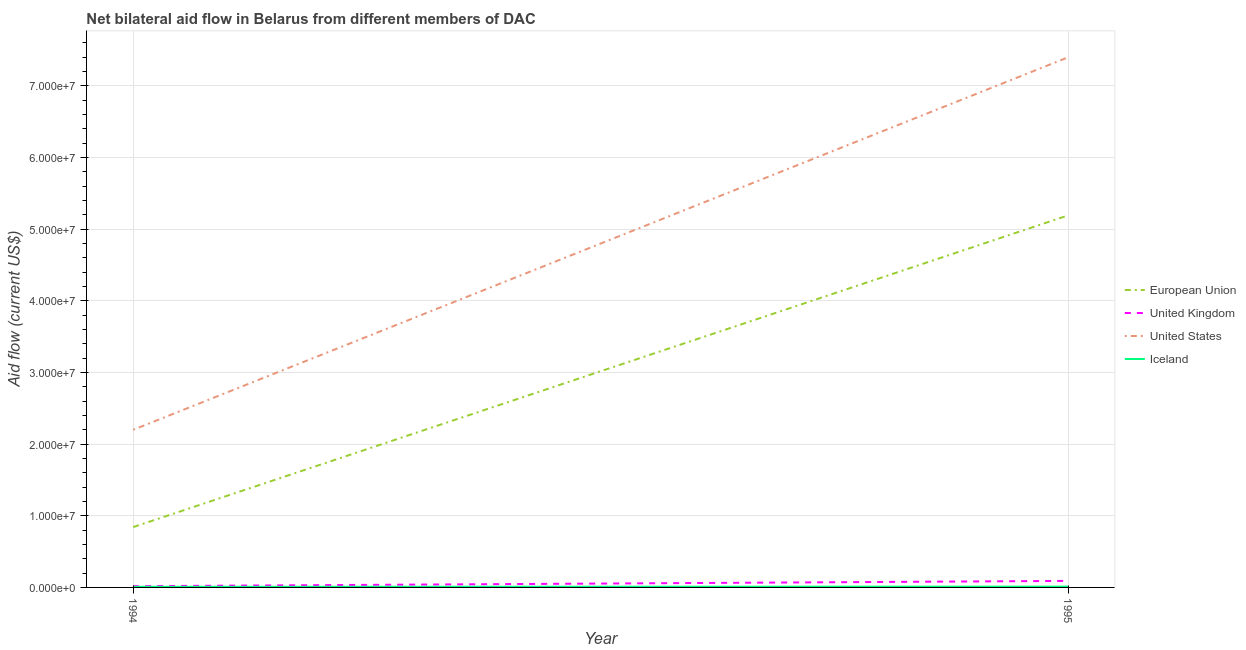How many different coloured lines are there?
Offer a very short reply. 4. Does the line corresponding to amount of aid given by us intersect with the line corresponding to amount of aid given by eu?
Your answer should be compact. No. What is the amount of aid given by eu in 1994?
Provide a succinct answer. 8.42e+06. Across all years, what is the maximum amount of aid given by eu?
Give a very brief answer. 5.19e+07. Across all years, what is the minimum amount of aid given by iceland?
Make the answer very short. 8.00e+04. In which year was the amount of aid given by uk maximum?
Keep it short and to the point. 1995. In which year was the amount of aid given by uk minimum?
Give a very brief answer. 1994. What is the total amount of aid given by eu in the graph?
Your response must be concise. 6.04e+07. What is the difference between the amount of aid given by eu in 1994 and that in 1995?
Provide a short and direct response. -4.35e+07. What is the difference between the amount of aid given by iceland in 1994 and the amount of aid given by eu in 1995?
Ensure brevity in your answer.  -5.18e+07. What is the average amount of aid given by uk per year?
Provide a short and direct response. 5.40e+05. In the year 1995, what is the difference between the amount of aid given by us and amount of aid given by iceland?
Give a very brief answer. 7.39e+07. In how many years, is the amount of aid given by us greater than 46000000 US$?
Give a very brief answer. 1. What is the ratio of the amount of aid given by uk in 1994 to that in 1995?
Your response must be concise. 0.19. Is the amount of aid given by iceland in 1994 less than that in 1995?
Keep it short and to the point. Yes. Is the amount of aid given by iceland strictly less than the amount of aid given by uk over the years?
Provide a succinct answer. Yes. How many lines are there?
Make the answer very short. 4. What is the difference between two consecutive major ticks on the Y-axis?
Ensure brevity in your answer.  1.00e+07. Are the values on the major ticks of Y-axis written in scientific E-notation?
Provide a succinct answer. Yes. Does the graph contain any zero values?
Offer a terse response. No. Where does the legend appear in the graph?
Provide a succinct answer. Center right. How many legend labels are there?
Provide a short and direct response. 4. How are the legend labels stacked?
Provide a short and direct response. Vertical. What is the title of the graph?
Keep it short and to the point. Net bilateral aid flow in Belarus from different members of DAC. What is the Aid flow (current US$) of European Union in 1994?
Offer a terse response. 8.42e+06. What is the Aid flow (current US$) in United Kingdom in 1994?
Your answer should be compact. 1.70e+05. What is the Aid flow (current US$) of United States in 1994?
Ensure brevity in your answer.  2.20e+07. What is the Aid flow (current US$) in Iceland in 1994?
Keep it short and to the point. 8.00e+04. What is the Aid flow (current US$) of European Union in 1995?
Your answer should be very brief. 5.19e+07. What is the Aid flow (current US$) in United Kingdom in 1995?
Your response must be concise. 9.10e+05. What is the Aid flow (current US$) in United States in 1995?
Ensure brevity in your answer.  7.40e+07. Across all years, what is the maximum Aid flow (current US$) in European Union?
Your answer should be very brief. 5.19e+07. Across all years, what is the maximum Aid flow (current US$) of United Kingdom?
Your answer should be very brief. 9.10e+05. Across all years, what is the maximum Aid flow (current US$) in United States?
Offer a terse response. 7.40e+07. Across all years, what is the maximum Aid flow (current US$) of Iceland?
Your response must be concise. 1.10e+05. Across all years, what is the minimum Aid flow (current US$) of European Union?
Offer a very short reply. 8.42e+06. Across all years, what is the minimum Aid flow (current US$) in United States?
Give a very brief answer. 2.20e+07. Across all years, what is the minimum Aid flow (current US$) of Iceland?
Make the answer very short. 8.00e+04. What is the total Aid flow (current US$) in European Union in the graph?
Offer a terse response. 6.04e+07. What is the total Aid flow (current US$) of United Kingdom in the graph?
Provide a succinct answer. 1.08e+06. What is the total Aid flow (current US$) of United States in the graph?
Ensure brevity in your answer.  9.60e+07. What is the difference between the Aid flow (current US$) of European Union in 1994 and that in 1995?
Provide a short and direct response. -4.35e+07. What is the difference between the Aid flow (current US$) in United Kingdom in 1994 and that in 1995?
Your answer should be very brief. -7.40e+05. What is the difference between the Aid flow (current US$) of United States in 1994 and that in 1995?
Give a very brief answer. -5.20e+07. What is the difference between the Aid flow (current US$) of European Union in 1994 and the Aid flow (current US$) of United Kingdom in 1995?
Keep it short and to the point. 7.51e+06. What is the difference between the Aid flow (current US$) in European Union in 1994 and the Aid flow (current US$) in United States in 1995?
Keep it short and to the point. -6.56e+07. What is the difference between the Aid flow (current US$) in European Union in 1994 and the Aid flow (current US$) in Iceland in 1995?
Offer a very short reply. 8.31e+06. What is the difference between the Aid flow (current US$) in United Kingdom in 1994 and the Aid flow (current US$) in United States in 1995?
Keep it short and to the point. -7.38e+07. What is the difference between the Aid flow (current US$) in United States in 1994 and the Aid flow (current US$) in Iceland in 1995?
Your answer should be very brief. 2.19e+07. What is the average Aid flow (current US$) of European Union per year?
Your answer should be very brief. 3.02e+07. What is the average Aid flow (current US$) of United Kingdom per year?
Offer a terse response. 5.40e+05. What is the average Aid flow (current US$) of United States per year?
Offer a terse response. 4.80e+07. What is the average Aid flow (current US$) in Iceland per year?
Offer a terse response. 9.50e+04. In the year 1994, what is the difference between the Aid flow (current US$) in European Union and Aid flow (current US$) in United Kingdom?
Provide a short and direct response. 8.25e+06. In the year 1994, what is the difference between the Aid flow (current US$) in European Union and Aid flow (current US$) in United States?
Your response must be concise. -1.36e+07. In the year 1994, what is the difference between the Aid flow (current US$) of European Union and Aid flow (current US$) of Iceland?
Keep it short and to the point. 8.34e+06. In the year 1994, what is the difference between the Aid flow (current US$) in United Kingdom and Aid flow (current US$) in United States?
Make the answer very short. -2.18e+07. In the year 1994, what is the difference between the Aid flow (current US$) in United States and Aid flow (current US$) in Iceland?
Give a very brief answer. 2.19e+07. In the year 1995, what is the difference between the Aid flow (current US$) in European Union and Aid flow (current US$) in United Kingdom?
Your answer should be compact. 5.10e+07. In the year 1995, what is the difference between the Aid flow (current US$) of European Union and Aid flow (current US$) of United States?
Ensure brevity in your answer.  -2.21e+07. In the year 1995, what is the difference between the Aid flow (current US$) of European Union and Aid flow (current US$) of Iceland?
Your answer should be compact. 5.18e+07. In the year 1995, what is the difference between the Aid flow (current US$) in United Kingdom and Aid flow (current US$) in United States?
Offer a terse response. -7.31e+07. In the year 1995, what is the difference between the Aid flow (current US$) in United Kingdom and Aid flow (current US$) in Iceland?
Give a very brief answer. 8.00e+05. In the year 1995, what is the difference between the Aid flow (current US$) in United States and Aid flow (current US$) in Iceland?
Provide a short and direct response. 7.39e+07. What is the ratio of the Aid flow (current US$) of European Union in 1994 to that in 1995?
Make the answer very short. 0.16. What is the ratio of the Aid flow (current US$) of United Kingdom in 1994 to that in 1995?
Your answer should be very brief. 0.19. What is the ratio of the Aid flow (current US$) in United States in 1994 to that in 1995?
Your answer should be very brief. 0.3. What is the ratio of the Aid flow (current US$) in Iceland in 1994 to that in 1995?
Provide a short and direct response. 0.73. What is the difference between the highest and the second highest Aid flow (current US$) of European Union?
Offer a terse response. 4.35e+07. What is the difference between the highest and the second highest Aid flow (current US$) in United Kingdom?
Your answer should be very brief. 7.40e+05. What is the difference between the highest and the second highest Aid flow (current US$) in United States?
Keep it short and to the point. 5.20e+07. What is the difference between the highest and the second highest Aid flow (current US$) of Iceland?
Provide a succinct answer. 3.00e+04. What is the difference between the highest and the lowest Aid flow (current US$) in European Union?
Keep it short and to the point. 4.35e+07. What is the difference between the highest and the lowest Aid flow (current US$) of United Kingdom?
Provide a short and direct response. 7.40e+05. What is the difference between the highest and the lowest Aid flow (current US$) of United States?
Keep it short and to the point. 5.20e+07. What is the difference between the highest and the lowest Aid flow (current US$) in Iceland?
Offer a very short reply. 3.00e+04. 